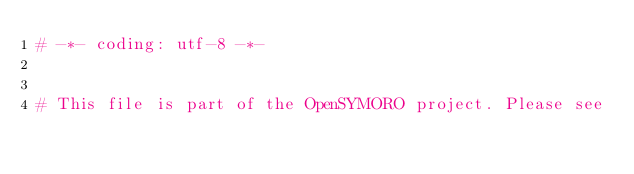Convert code to text. <code><loc_0><loc_0><loc_500><loc_500><_Python_># -*- coding: utf-8 -*-


# This file is part of the OpenSYMORO project. Please see</code> 